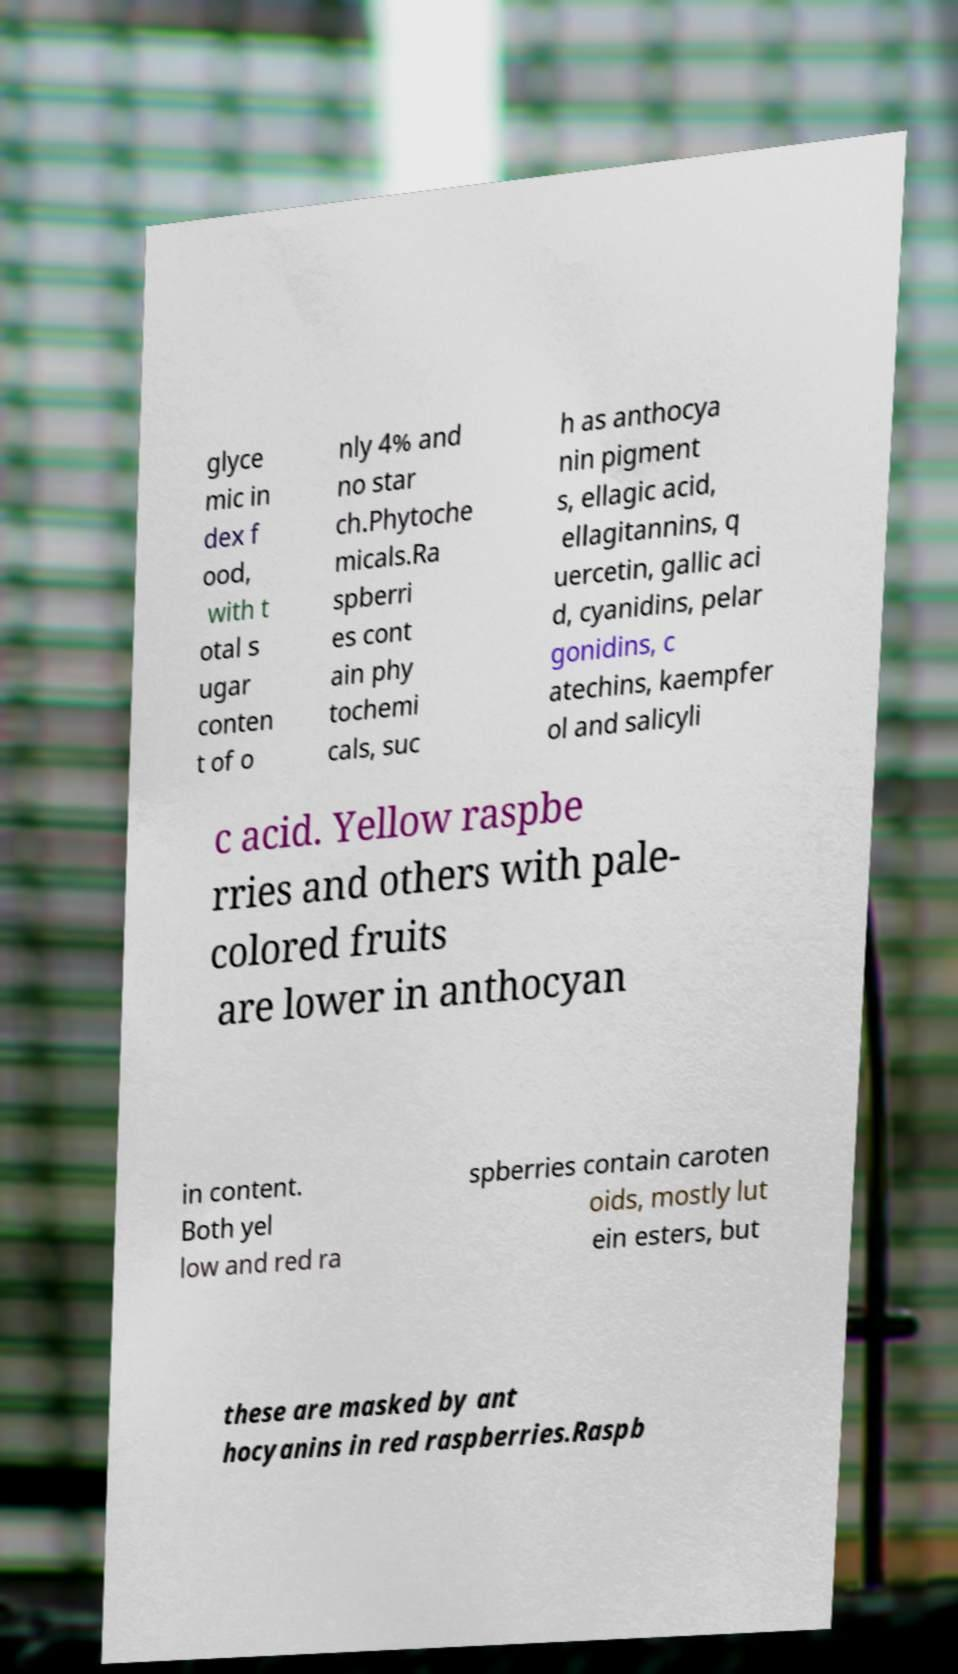Could you extract and type out the text from this image? glyce mic in dex f ood, with t otal s ugar conten t of o nly 4% and no star ch.Phytoche micals.Ra spberri es cont ain phy tochemi cals, suc h as anthocya nin pigment s, ellagic acid, ellagitannins, q uercetin, gallic aci d, cyanidins, pelar gonidins, c atechins, kaempfer ol and salicyli c acid. Yellow raspbe rries and others with pale- colored fruits are lower in anthocyan in content. Both yel low and red ra spberries contain caroten oids, mostly lut ein esters, but these are masked by ant hocyanins in red raspberries.Raspb 